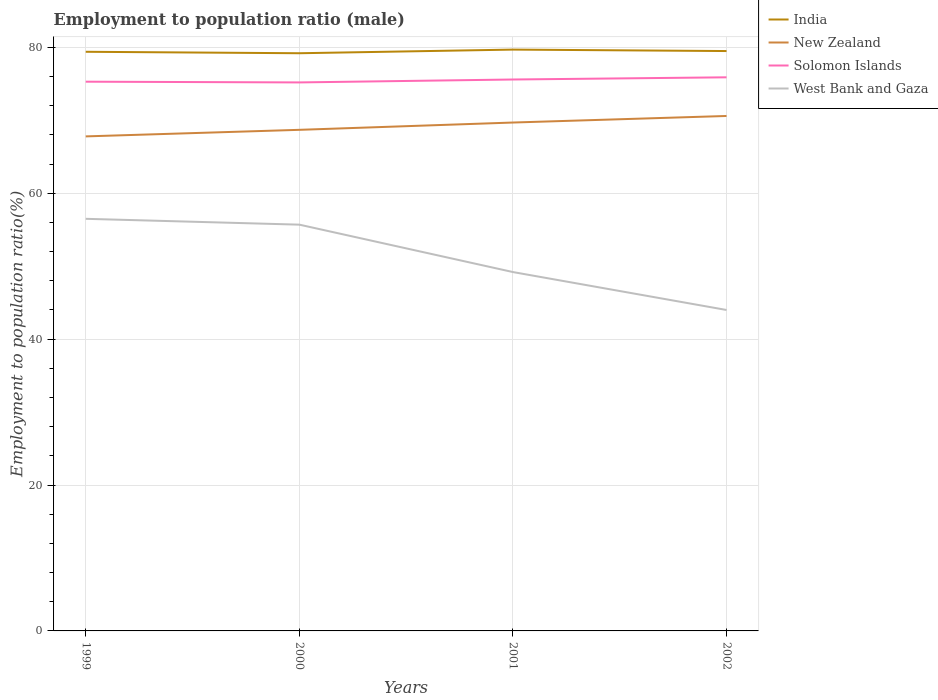Across all years, what is the maximum employment to population ratio in New Zealand?
Your answer should be compact. 67.8. What is the total employment to population ratio in India in the graph?
Your answer should be compact. 0.2. What is the difference between the highest and the second highest employment to population ratio in Solomon Islands?
Keep it short and to the point. 0.7. What is the difference between the highest and the lowest employment to population ratio in India?
Provide a short and direct response. 2. How many years are there in the graph?
Give a very brief answer. 4. How are the legend labels stacked?
Your answer should be very brief. Vertical. What is the title of the graph?
Keep it short and to the point. Employment to population ratio (male). What is the label or title of the X-axis?
Offer a terse response. Years. What is the label or title of the Y-axis?
Offer a very short reply. Employment to population ratio(%). What is the Employment to population ratio(%) in India in 1999?
Offer a terse response. 79.4. What is the Employment to population ratio(%) in New Zealand in 1999?
Provide a short and direct response. 67.8. What is the Employment to population ratio(%) of Solomon Islands in 1999?
Make the answer very short. 75.3. What is the Employment to population ratio(%) in West Bank and Gaza in 1999?
Give a very brief answer. 56.5. What is the Employment to population ratio(%) in India in 2000?
Offer a terse response. 79.2. What is the Employment to population ratio(%) in New Zealand in 2000?
Make the answer very short. 68.7. What is the Employment to population ratio(%) in Solomon Islands in 2000?
Offer a terse response. 75.2. What is the Employment to population ratio(%) of West Bank and Gaza in 2000?
Give a very brief answer. 55.7. What is the Employment to population ratio(%) of India in 2001?
Keep it short and to the point. 79.7. What is the Employment to population ratio(%) in New Zealand in 2001?
Make the answer very short. 69.7. What is the Employment to population ratio(%) of Solomon Islands in 2001?
Give a very brief answer. 75.6. What is the Employment to population ratio(%) of West Bank and Gaza in 2001?
Provide a succinct answer. 49.2. What is the Employment to population ratio(%) of India in 2002?
Make the answer very short. 79.5. What is the Employment to population ratio(%) in New Zealand in 2002?
Keep it short and to the point. 70.6. What is the Employment to population ratio(%) in Solomon Islands in 2002?
Make the answer very short. 75.9. Across all years, what is the maximum Employment to population ratio(%) of India?
Ensure brevity in your answer.  79.7. Across all years, what is the maximum Employment to population ratio(%) in New Zealand?
Your answer should be very brief. 70.6. Across all years, what is the maximum Employment to population ratio(%) of Solomon Islands?
Offer a terse response. 75.9. Across all years, what is the maximum Employment to population ratio(%) in West Bank and Gaza?
Offer a very short reply. 56.5. Across all years, what is the minimum Employment to population ratio(%) in India?
Your response must be concise. 79.2. Across all years, what is the minimum Employment to population ratio(%) in New Zealand?
Ensure brevity in your answer.  67.8. Across all years, what is the minimum Employment to population ratio(%) in Solomon Islands?
Keep it short and to the point. 75.2. Across all years, what is the minimum Employment to population ratio(%) of West Bank and Gaza?
Your answer should be compact. 44. What is the total Employment to population ratio(%) in India in the graph?
Keep it short and to the point. 317.8. What is the total Employment to population ratio(%) in New Zealand in the graph?
Give a very brief answer. 276.8. What is the total Employment to population ratio(%) in Solomon Islands in the graph?
Ensure brevity in your answer.  302. What is the total Employment to population ratio(%) of West Bank and Gaza in the graph?
Your answer should be very brief. 205.4. What is the difference between the Employment to population ratio(%) of India in 1999 and that in 2000?
Offer a terse response. 0.2. What is the difference between the Employment to population ratio(%) of Solomon Islands in 1999 and that in 2000?
Offer a terse response. 0.1. What is the difference between the Employment to population ratio(%) in India in 1999 and that in 2001?
Offer a terse response. -0.3. What is the difference between the Employment to population ratio(%) of New Zealand in 1999 and that in 2001?
Your response must be concise. -1.9. What is the difference between the Employment to population ratio(%) in Solomon Islands in 1999 and that in 2001?
Offer a terse response. -0.3. What is the difference between the Employment to population ratio(%) in New Zealand in 1999 and that in 2002?
Provide a short and direct response. -2.8. What is the difference between the Employment to population ratio(%) of West Bank and Gaza in 1999 and that in 2002?
Make the answer very short. 12.5. What is the difference between the Employment to population ratio(%) in India in 2000 and that in 2001?
Ensure brevity in your answer.  -0.5. What is the difference between the Employment to population ratio(%) in Solomon Islands in 2000 and that in 2001?
Provide a succinct answer. -0.4. What is the difference between the Employment to population ratio(%) in West Bank and Gaza in 2000 and that in 2002?
Offer a very short reply. 11.7. What is the difference between the Employment to population ratio(%) of Solomon Islands in 2001 and that in 2002?
Keep it short and to the point. -0.3. What is the difference between the Employment to population ratio(%) of West Bank and Gaza in 2001 and that in 2002?
Offer a terse response. 5.2. What is the difference between the Employment to population ratio(%) of India in 1999 and the Employment to population ratio(%) of Solomon Islands in 2000?
Offer a very short reply. 4.2. What is the difference between the Employment to population ratio(%) in India in 1999 and the Employment to population ratio(%) in West Bank and Gaza in 2000?
Provide a short and direct response. 23.7. What is the difference between the Employment to population ratio(%) of Solomon Islands in 1999 and the Employment to population ratio(%) of West Bank and Gaza in 2000?
Your answer should be very brief. 19.6. What is the difference between the Employment to population ratio(%) of India in 1999 and the Employment to population ratio(%) of Solomon Islands in 2001?
Your response must be concise. 3.8. What is the difference between the Employment to population ratio(%) of India in 1999 and the Employment to population ratio(%) of West Bank and Gaza in 2001?
Make the answer very short. 30.2. What is the difference between the Employment to population ratio(%) in New Zealand in 1999 and the Employment to population ratio(%) in Solomon Islands in 2001?
Give a very brief answer. -7.8. What is the difference between the Employment to population ratio(%) in Solomon Islands in 1999 and the Employment to population ratio(%) in West Bank and Gaza in 2001?
Make the answer very short. 26.1. What is the difference between the Employment to population ratio(%) in India in 1999 and the Employment to population ratio(%) in New Zealand in 2002?
Ensure brevity in your answer.  8.8. What is the difference between the Employment to population ratio(%) of India in 1999 and the Employment to population ratio(%) of Solomon Islands in 2002?
Make the answer very short. 3.5. What is the difference between the Employment to population ratio(%) in India in 1999 and the Employment to population ratio(%) in West Bank and Gaza in 2002?
Give a very brief answer. 35.4. What is the difference between the Employment to population ratio(%) in New Zealand in 1999 and the Employment to population ratio(%) in Solomon Islands in 2002?
Your response must be concise. -8.1. What is the difference between the Employment to population ratio(%) in New Zealand in 1999 and the Employment to population ratio(%) in West Bank and Gaza in 2002?
Your response must be concise. 23.8. What is the difference between the Employment to population ratio(%) in Solomon Islands in 1999 and the Employment to population ratio(%) in West Bank and Gaza in 2002?
Provide a succinct answer. 31.3. What is the difference between the Employment to population ratio(%) in India in 2000 and the Employment to population ratio(%) in New Zealand in 2001?
Offer a very short reply. 9.5. What is the difference between the Employment to population ratio(%) in India in 2000 and the Employment to population ratio(%) in Solomon Islands in 2001?
Provide a short and direct response. 3.6. What is the difference between the Employment to population ratio(%) in New Zealand in 2000 and the Employment to population ratio(%) in Solomon Islands in 2001?
Provide a succinct answer. -6.9. What is the difference between the Employment to population ratio(%) of New Zealand in 2000 and the Employment to population ratio(%) of West Bank and Gaza in 2001?
Make the answer very short. 19.5. What is the difference between the Employment to population ratio(%) of Solomon Islands in 2000 and the Employment to population ratio(%) of West Bank and Gaza in 2001?
Your answer should be compact. 26. What is the difference between the Employment to population ratio(%) in India in 2000 and the Employment to population ratio(%) in West Bank and Gaza in 2002?
Keep it short and to the point. 35.2. What is the difference between the Employment to population ratio(%) of New Zealand in 2000 and the Employment to population ratio(%) of West Bank and Gaza in 2002?
Make the answer very short. 24.7. What is the difference between the Employment to population ratio(%) of Solomon Islands in 2000 and the Employment to population ratio(%) of West Bank and Gaza in 2002?
Keep it short and to the point. 31.2. What is the difference between the Employment to population ratio(%) in India in 2001 and the Employment to population ratio(%) in New Zealand in 2002?
Provide a short and direct response. 9.1. What is the difference between the Employment to population ratio(%) in India in 2001 and the Employment to population ratio(%) in Solomon Islands in 2002?
Provide a short and direct response. 3.8. What is the difference between the Employment to population ratio(%) of India in 2001 and the Employment to population ratio(%) of West Bank and Gaza in 2002?
Make the answer very short. 35.7. What is the difference between the Employment to population ratio(%) in New Zealand in 2001 and the Employment to population ratio(%) in Solomon Islands in 2002?
Ensure brevity in your answer.  -6.2. What is the difference between the Employment to population ratio(%) in New Zealand in 2001 and the Employment to population ratio(%) in West Bank and Gaza in 2002?
Provide a short and direct response. 25.7. What is the difference between the Employment to population ratio(%) of Solomon Islands in 2001 and the Employment to population ratio(%) of West Bank and Gaza in 2002?
Keep it short and to the point. 31.6. What is the average Employment to population ratio(%) of India per year?
Your response must be concise. 79.45. What is the average Employment to population ratio(%) in New Zealand per year?
Provide a succinct answer. 69.2. What is the average Employment to population ratio(%) of Solomon Islands per year?
Give a very brief answer. 75.5. What is the average Employment to population ratio(%) of West Bank and Gaza per year?
Offer a very short reply. 51.35. In the year 1999, what is the difference between the Employment to population ratio(%) in India and Employment to population ratio(%) in New Zealand?
Offer a very short reply. 11.6. In the year 1999, what is the difference between the Employment to population ratio(%) in India and Employment to population ratio(%) in West Bank and Gaza?
Provide a succinct answer. 22.9. In the year 1999, what is the difference between the Employment to population ratio(%) in New Zealand and Employment to population ratio(%) in Solomon Islands?
Keep it short and to the point. -7.5. In the year 1999, what is the difference between the Employment to population ratio(%) of New Zealand and Employment to population ratio(%) of West Bank and Gaza?
Keep it short and to the point. 11.3. In the year 2000, what is the difference between the Employment to population ratio(%) in India and Employment to population ratio(%) in New Zealand?
Make the answer very short. 10.5. In the year 2000, what is the difference between the Employment to population ratio(%) in India and Employment to population ratio(%) in West Bank and Gaza?
Ensure brevity in your answer.  23.5. In the year 2000, what is the difference between the Employment to population ratio(%) in New Zealand and Employment to population ratio(%) in Solomon Islands?
Ensure brevity in your answer.  -6.5. In the year 2000, what is the difference between the Employment to population ratio(%) in New Zealand and Employment to population ratio(%) in West Bank and Gaza?
Give a very brief answer. 13. In the year 2001, what is the difference between the Employment to population ratio(%) in India and Employment to population ratio(%) in Solomon Islands?
Give a very brief answer. 4.1. In the year 2001, what is the difference between the Employment to population ratio(%) in India and Employment to population ratio(%) in West Bank and Gaza?
Offer a very short reply. 30.5. In the year 2001, what is the difference between the Employment to population ratio(%) of New Zealand and Employment to population ratio(%) of Solomon Islands?
Give a very brief answer. -5.9. In the year 2001, what is the difference between the Employment to population ratio(%) in New Zealand and Employment to population ratio(%) in West Bank and Gaza?
Provide a short and direct response. 20.5. In the year 2001, what is the difference between the Employment to population ratio(%) in Solomon Islands and Employment to population ratio(%) in West Bank and Gaza?
Ensure brevity in your answer.  26.4. In the year 2002, what is the difference between the Employment to population ratio(%) of India and Employment to population ratio(%) of New Zealand?
Give a very brief answer. 8.9. In the year 2002, what is the difference between the Employment to population ratio(%) in India and Employment to population ratio(%) in West Bank and Gaza?
Your response must be concise. 35.5. In the year 2002, what is the difference between the Employment to population ratio(%) in New Zealand and Employment to population ratio(%) in West Bank and Gaza?
Offer a terse response. 26.6. In the year 2002, what is the difference between the Employment to population ratio(%) of Solomon Islands and Employment to population ratio(%) of West Bank and Gaza?
Offer a very short reply. 31.9. What is the ratio of the Employment to population ratio(%) in India in 1999 to that in 2000?
Provide a succinct answer. 1. What is the ratio of the Employment to population ratio(%) in New Zealand in 1999 to that in 2000?
Offer a terse response. 0.99. What is the ratio of the Employment to population ratio(%) of Solomon Islands in 1999 to that in 2000?
Offer a very short reply. 1. What is the ratio of the Employment to population ratio(%) in West Bank and Gaza in 1999 to that in 2000?
Keep it short and to the point. 1.01. What is the ratio of the Employment to population ratio(%) in India in 1999 to that in 2001?
Keep it short and to the point. 1. What is the ratio of the Employment to population ratio(%) of New Zealand in 1999 to that in 2001?
Give a very brief answer. 0.97. What is the ratio of the Employment to population ratio(%) of West Bank and Gaza in 1999 to that in 2001?
Give a very brief answer. 1.15. What is the ratio of the Employment to population ratio(%) in India in 1999 to that in 2002?
Your answer should be very brief. 1. What is the ratio of the Employment to population ratio(%) in New Zealand in 1999 to that in 2002?
Make the answer very short. 0.96. What is the ratio of the Employment to population ratio(%) of Solomon Islands in 1999 to that in 2002?
Offer a very short reply. 0.99. What is the ratio of the Employment to population ratio(%) in West Bank and Gaza in 1999 to that in 2002?
Provide a succinct answer. 1.28. What is the ratio of the Employment to population ratio(%) of New Zealand in 2000 to that in 2001?
Your response must be concise. 0.99. What is the ratio of the Employment to population ratio(%) of Solomon Islands in 2000 to that in 2001?
Your answer should be compact. 0.99. What is the ratio of the Employment to population ratio(%) of West Bank and Gaza in 2000 to that in 2001?
Your answer should be compact. 1.13. What is the ratio of the Employment to population ratio(%) in India in 2000 to that in 2002?
Make the answer very short. 1. What is the ratio of the Employment to population ratio(%) of New Zealand in 2000 to that in 2002?
Ensure brevity in your answer.  0.97. What is the ratio of the Employment to population ratio(%) in West Bank and Gaza in 2000 to that in 2002?
Provide a succinct answer. 1.27. What is the ratio of the Employment to population ratio(%) in New Zealand in 2001 to that in 2002?
Your response must be concise. 0.99. What is the ratio of the Employment to population ratio(%) of Solomon Islands in 2001 to that in 2002?
Give a very brief answer. 1. What is the ratio of the Employment to population ratio(%) of West Bank and Gaza in 2001 to that in 2002?
Provide a short and direct response. 1.12. What is the difference between the highest and the second highest Employment to population ratio(%) of India?
Give a very brief answer. 0.2. What is the difference between the highest and the second highest Employment to population ratio(%) in New Zealand?
Your response must be concise. 0.9. What is the difference between the highest and the second highest Employment to population ratio(%) of Solomon Islands?
Provide a short and direct response. 0.3. What is the difference between the highest and the lowest Employment to population ratio(%) in Solomon Islands?
Offer a very short reply. 0.7. 